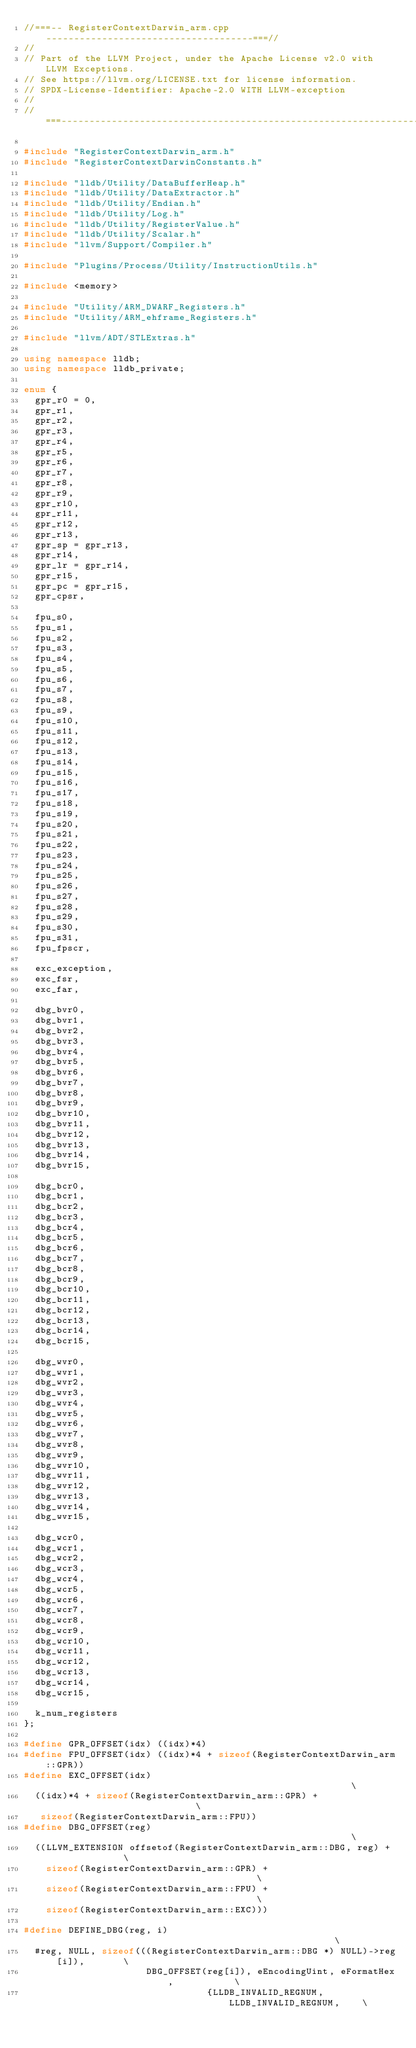Convert code to text. <code><loc_0><loc_0><loc_500><loc_500><_C++_>//===-- RegisterContextDarwin_arm.cpp -------------------------------------===//
//
// Part of the LLVM Project, under the Apache License v2.0 with LLVM Exceptions.
// See https://llvm.org/LICENSE.txt for license information.
// SPDX-License-Identifier: Apache-2.0 WITH LLVM-exception
//
//===----------------------------------------------------------------------===//

#include "RegisterContextDarwin_arm.h"
#include "RegisterContextDarwinConstants.h"

#include "lldb/Utility/DataBufferHeap.h"
#include "lldb/Utility/DataExtractor.h"
#include "lldb/Utility/Endian.h"
#include "lldb/Utility/Log.h"
#include "lldb/Utility/RegisterValue.h"
#include "lldb/Utility/Scalar.h"
#include "llvm/Support/Compiler.h"

#include "Plugins/Process/Utility/InstructionUtils.h"

#include <memory>

#include "Utility/ARM_DWARF_Registers.h"
#include "Utility/ARM_ehframe_Registers.h"

#include "llvm/ADT/STLExtras.h"

using namespace lldb;
using namespace lldb_private;

enum {
  gpr_r0 = 0,
  gpr_r1,
  gpr_r2,
  gpr_r3,
  gpr_r4,
  gpr_r5,
  gpr_r6,
  gpr_r7,
  gpr_r8,
  gpr_r9,
  gpr_r10,
  gpr_r11,
  gpr_r12,
  gpr_r13,
  gpr_sp = gpr_r13,
  gpr_r14,
  gpr_lr = gpr_r14,
  gpr_r15,
  gpr_pc = gpr_r15,
  gpr_cpsr,

  fpu_s0,
  fpu_s1,
  fpu_s2,
  fpu_s3,
  fpu_s4,
  fpu_s5,
  fpu_s6,
  fpu_s7,
  fpu_s8,
  fpu_s9,
  fpu_s10,
  fpu_s11,
  fpu_s12,
  fpu_s13,
  fpu_s14,
  fpu_s15,
  fpu_s16,
  fpu_s17,
  fpu_s18,
  fpu_s19,
  fpu_s20,
  fpu_s21,
  fpu_s22,
  fpu_s23,
  fpu_s24,
  fpu_s25,
  fpu_s26,
  fpu_s27,
  fpu_s28,
  fpu_s29,
  fpu_s30,
  fpu_s31,
  fpu_fpscr,

  exc_exception,
  exc_fsr,
  exc_far,

  dbg_bvr0,
  dbg_bvr1,
  dbg_bvr2,
  dbg_bvr3,
  dbg_bvr4,
  dbg_bvr5,
  dbg_bvr6,
  dbg_bvr7,
  dbg_bvr8,
  dbg_bvr9,
  dbg_bvr10,
  dbg_bvr11,
  dbg_bvr12,
  dbg_bvr13,
  dbg_bvr14,
  dbg_bvr15,

  dbg_bcr0,
  dbg_bcr1,
  dbg_bcr2,
  dbg_bcr3,
  dbg_bcr4,
  dbg_bcr5,
  dbg_bcr6,
  dbg_bcr7,
  dbg_bcr8,
  dbg_bcr9,
  dbg_bcr10,
  dbg_bcr11,
  dbg_bcr12,
  dbg_bcr13,
  dbg_bcr14,
  dbg_bcr15,

  dbg_wvr0,
  dbg_wvr1,
  dbg_wvr2,
  dbg_wvr3,
  dbg_wvr4,
  dbg_wvr5,
  dbg_wvr6,
  dbg_wvr7,
  dbg_wvr8,
  dbg_wvr9,
  dbg_wvr10,
  dbg_wvr11,
  dbg_wvr12,
  dbg_wvr13,
  dbg_wvr14,
  dbg_wvr15,

  dbg_wcr0,
  dbg_wcr1,
  dbg_wcr2,
  dbg_wcr3,
  dbg_wcr4,
  dbg_wcr5,
  dbg_wcr6,
  dbg_wcr7,
  dbg_wcr8,
  dbg_wcr9,
  dbg_wcr10,
  dbg_wcr11,
  dbg_wcr12,
  dbg_wcr13,
  dbg_wcr14,
  dbg_wcr15,

  k_num_registers
};

#define GPR_OFFSET(idx) ((idx)*4)
#define FPU_OFFSET(idx) ((idx)*4 + sizeof(RegisterContextDarwin_arm::GPR))
#define EXC_OFFSET(idx)                                                        \
  ((idx)*4 + sizeof(RegisterContextDarwin_arm::GPR) +                          \
   sizeof(RegisterContextDarwin_arm::FPU))
#define DBG_OFFSET(reg)                                                        \
  ((LLVM_EXTENSION offsetof(RegisterContextDarwin_arm::DBG, reg) +             \
    sizeof(RegisterContextDarwin_arm::GPR) +                                   \
    sizeof(RegisterContextDarwin_arm::FPU) +                                   \
    sizeof(RegisterContextDarwin_arm::EXC)))

#define DEFINE_DBG(reg, i)                                                     \
  #reg, NULL, sizeof(((RegisterContextDarwin_arm::DBG *) NULL)->reg[i]),       \
                      DBG_OFFSET(reg[i]), eEncodingUint, eFormatHex,           \
                                 {LLDB_INVALID_REGNUM, LLDB_INVALID_REGNUM,    \</code> 